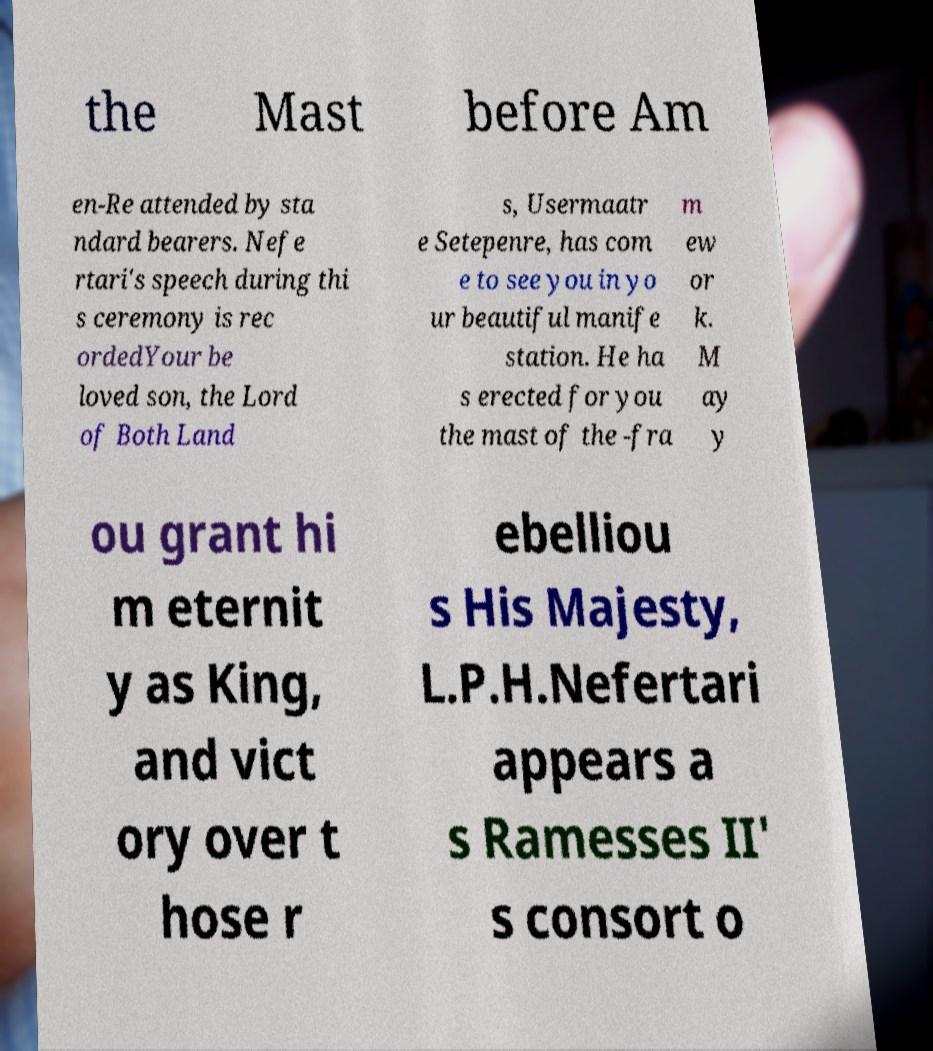Please identify and transcribe the text found in this image. the Mast before Am en-Re attended by sta ndard bearers. Nefe rtari's speech during thi s ceremony is rec ordedYour be loved son, the Lord of Both Land s, Usermaatr e Setepenre, has com e to see you in yo ur beautiful manife station. He ha s erected for you the mast of the -fra m ew or k. M ay y ou grant hi m eternit y as King, and vict ory over t hose r ebelliou s His Majesty, L.P.H.Nefertari appears a s Ramesses II' s consort o 